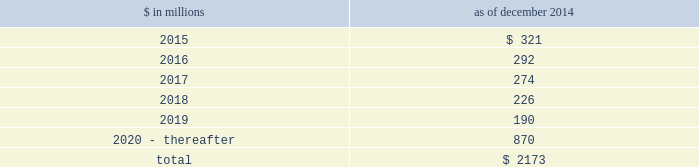Notes to consolidated financial statements sumitomo mitsui financial group , inc .
( smfg ) provides the firm with credit loss protection on certain approved loan commitments ( primarily investment-grade commercial lending commitments ) .
The notional amount of such loan commitments was $ 27.51 billion and $ 29.24 billion as of december 2014 and december 2013 , respectively .
The credit loss protection on loan commitments provided by smfg is generally limited to 95% ( 95 % ) of the first loss the firm realizes on such commitments , up to a maximum of approximately $ 950 million .
In addition , subject to the satisfaction of certain conditions , upon the firm 2019s request , smfg will provide protection for 70% ( 70 % ) of additional losses on such commitments , up to a maximum of $ 1.13 billion , of which $ 768 million and $ 870 million of protection had been provided as of december 2014 and december 2013 , respectively .
The firm also uses other financial instruments to mitigate credit risks related to certain commitments not covered by smfg .
These instruments primarily include credit default swaps that reference the same or similar underlying instrument or entity , or credit default swaps that reference a market index .
Warehouse financing .
The firm provides financing to clients who warehouse financial assets .
These arrangements are secured by the warehoused assets , primarily consisting of corporate loans and commercial mortgage loans .
Contingent and forward starting resale and securities borrowing agreements/forward starting repurchase and secured lending agreements the firm enters into resale and securities borrowing agreements and repurchase and secured lending agreements that settle at a future date , generally within three business days .
The firm also enters into commitments to provide contingent financing to its clients and counterparties through resale agreements .
The firm 2019s funding of these commitments depends on the satisfaction of all contractual conditions to the resale agreement and these commitments can expire unused .
Letters of credit the firm has commitments under letters of credit issued by various banks which the firm provides to counterparties in lieu of securities or cash to satisfy various collateral and margin deposit requirements .
Investment commitments the firm 2019s investment commitments of $ 5.16 billion and $ 7.12 billion as of december 2014 and december 2013 , respectively , include commitments to invest in private equity , real estate and other assets directly and through funds that the firm raises and manages .
Of these amounts , $ 2.87 billion and $ 5.48 billion as of december 2014 and december 2013 , respectively , relate to commitments to invest in funds managed by the firm .
If these commitments are called , they would be funded at market value on the date of investment .
Leases the firm has contractual obligations under long-term noncancelable lease agreements , principally for office space , expiring on various dates through 2069 .
Certain agreements are subject to periodic escalation provisions for increases in real estate taxes and other charges .
The table below presents future minimum rental payments , net of minimum sublease rentals .
$ in millions december 2014 .
Rent charged to operating expense was $ 309 million for 2014 , $ 324 million for 2013 and $ 374 million for 2012 .
Operating leases include office space held in excess of current requirements .
Rent expense relating to space held for growth is included in 201coccupancy . 201d the firm records a liability , based on the fair value of the remaining lease rentals reduced by any potential or existing sublease rentals , for leases where the firm has ceased using the space and management has concluded that the firm will not derive any future economic benefits .
Costs to terminate a lease before the end of its term are recognized and measured at fair value on termination .
Goldman sachs 2014 annual report 165 .
What percentage of future minimum rental payments is due in 2016? 
Computations: (292 / 2173)
Answer: 0.13438. 